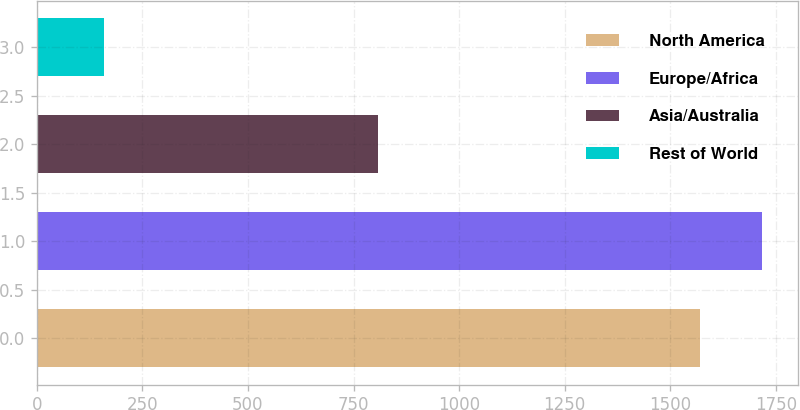<chart> <loc_0><loc_0><loc_500><loc_500><bar_chart><fcel>North America<fcel>Europe/Africa<fcel>Asia/Australia<fcel>Rest of World<nl><fcel>1570<fcel>1716.6<fcel>809<fcel>159<nl></chart> 